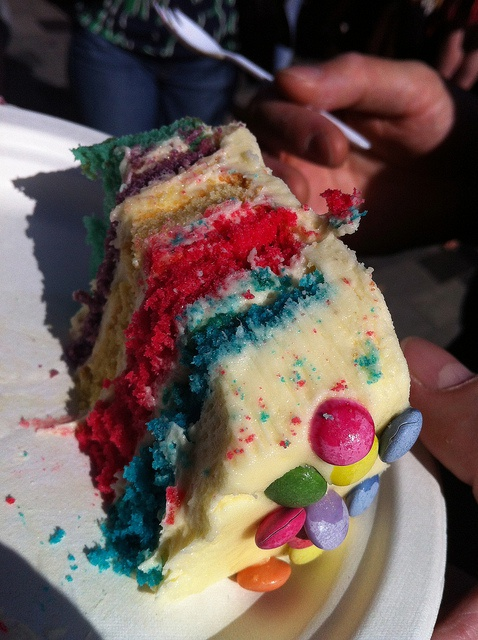Describe the objects in this image and their specific colors. I can see cake in black, tan, maroon, and darkgray tones, people in black, maroon, and brown tones, people in black, teal, and gray tones, and fork in black, gray, lavender, and darkgray tones in this image. 